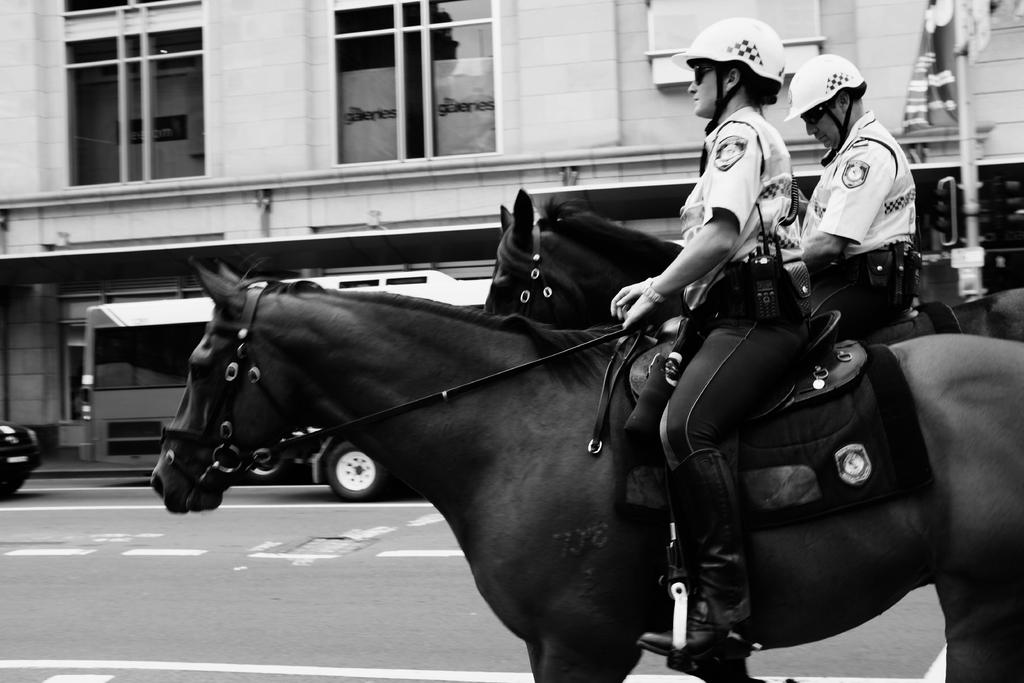How many people are in the image? There are two people in the image. What are the two people doing in the image? The two people are riding a horse. Where is the horse located in the image? The horse is on a road. What can be seen in the background of the image? There are buildings and vehicles in the background of the image. What type of bike is the spy riding in the image? There is no bike or spy present in the image; it features two people riding a horse on a road with buildings and vehicles in the background. 